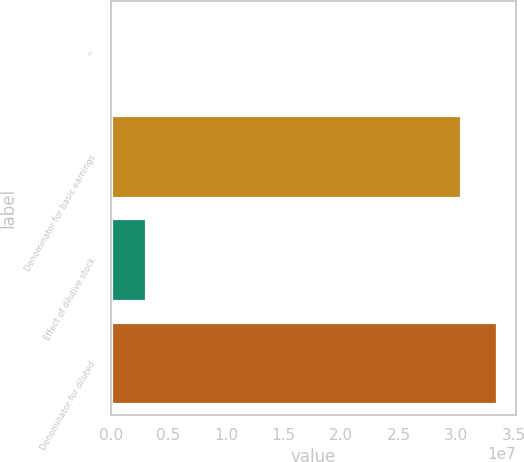Convert chart. <chart><loc_0><loc_0><loc_500><loc_500><bar_chart><fcel>^<fcel>Denominator for basic earnings<fcel>Effect of dilutive stock<fcel>Denominator for diluted<nl><fcel>2006<fcel>3.04061e+07<fcel>3.10219e+06<fcel>3.35063e+07<nl></chart> 